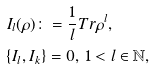Convert formula to latex. <formula><loc_0><loc_0><loc_500><loc_500>& I _ { l } ( \rho ) \colon = \frac { 1 } { l } T r \rho ^ { l } , \\ & \{ I _ { l } , I _ { k } \} = 0 , \, 1 < l \in \mathbb { N } ,</formula> 